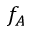<formula> <loc_0><loc_0><loc_500><loc_500>f _ { A }</formula> 